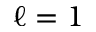<formula> <loc_0><loc_0><loc_500><loc_500>\ell = 1</formula> 